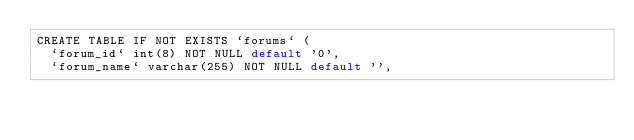Convert code to text. <code><loc_0><loc_0><loc_500><loc_500><_SQL_>CREATE TABLE IF NOT EXISTS `forums` (
  `forum_id` int(8) NOT NULL default '0',
  `forum_name` varchar(255) NOT NULL default '',</code> 